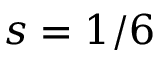<formula> <loc_0><loc_0><loc_500><loc_500>s = 1 / 6</formula> 